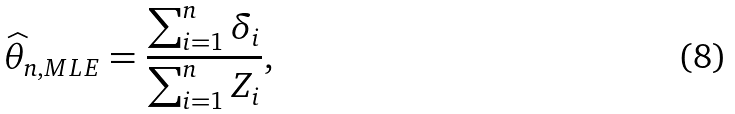Convert formula to latex. <formula><loc_0><loc_0><loc_500><loc_500>\widehat { \theta } _ { n , M L E } = \frac { \sum _ { i = 1 } ^ { n } \delta _ { i } } { \sum _ { i = 1 } ^ { n } Z _ { i } } ,</formula> 